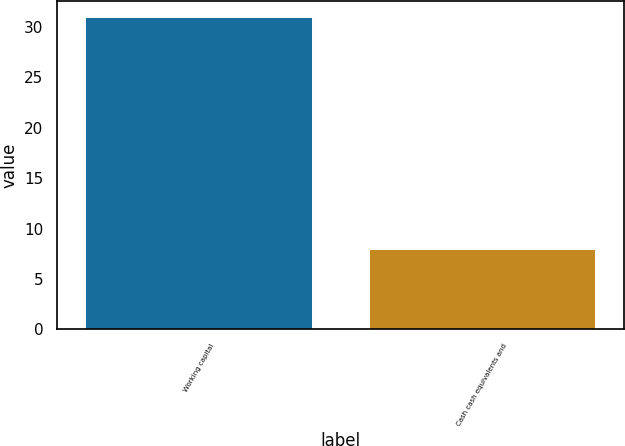Convert chart to OTSL. <chart><loc_0><loc_0><loc_500><loc_500><bar_chart><fcel>Working capital<fcel>Cash cash equivalents and<nl><fcel>31<fcel>8<nl></chart> 